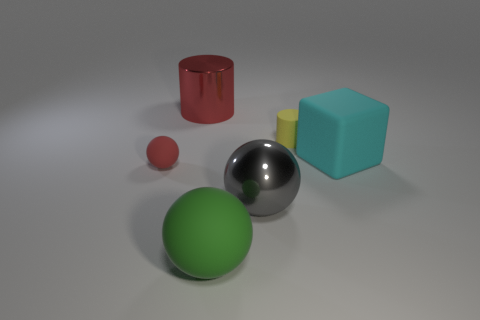Add 3 red shiny cylinders. How many objects exist? 9 Subtract all blocks. How many objects are left? 5 Subtract all tiny yellow rubber things. Subtract all red shiny cylinders. How many objects are left? 4 Add 1 shiny cylinders. How many shiny cylinders are left? 2 Add 4 small yellow matte cylinders. How many small yellow matte cylinders exist? 5 Subtract 0 gray cubes. How many objects are left? 6 